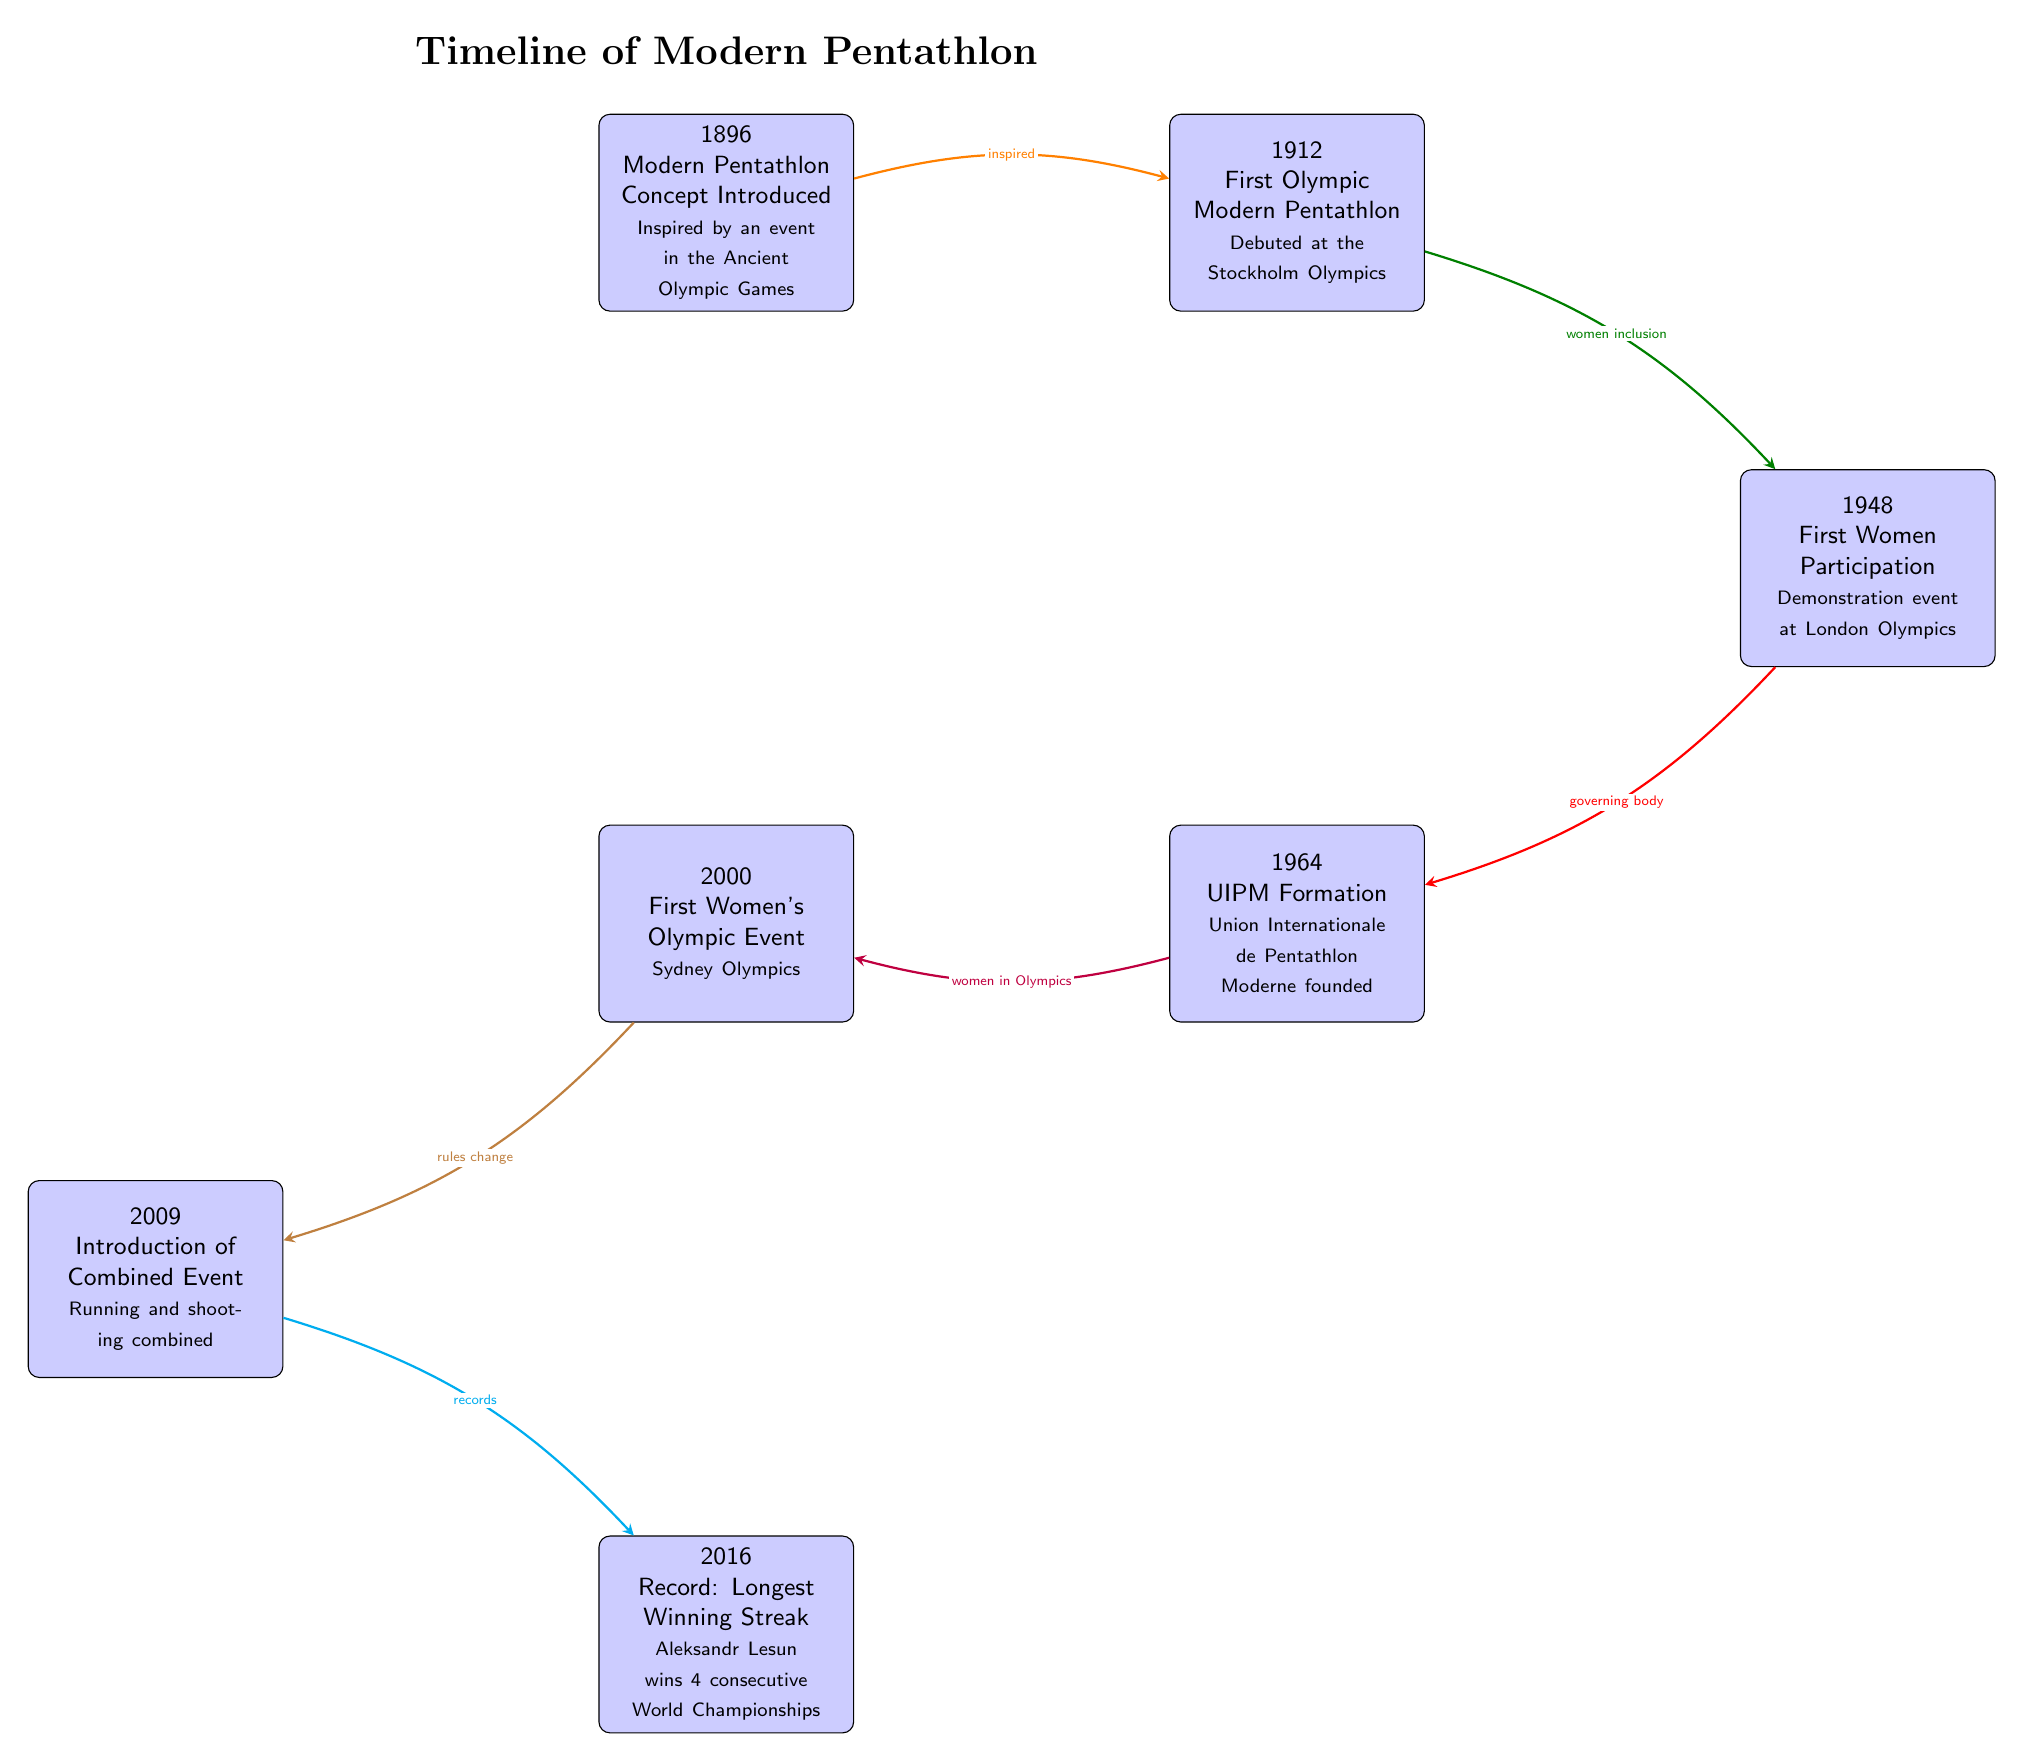What year was the Modern Pentathlon concept introduced? The diagram shows the node labeled "1896," which includes the text "Modern Pentathlon Concept Introduced." Therefore, the year mentioned is 1896.
Answer: 1896 What significant event related to women in modern pentathlon occurred in 1948? The node for the year "1948" specifies "First Women Participation," indicating that this was the significant event pertaining to women in modern pentathlon that year.
Answer: First Women Participation How many major events are listed in the timeline? By counting the event nodes in the diagram, we see there are 6: 1896, 1912, 1948, 1964, 2000, 2009, and 2016, resulting in a total of 6.
Answer: 6 What record was set in 2016? The node for the year "2016" notes "Record: Longest Winning Streak," which identifies the specific record that was achieved that year.
Answer: Longest Winning Streak What relationship does the arrow from 1896 to 1912 represent? The arrow from "1896" to "1912" is labeled "inspired," indicating that the introduction of modern pentathlon in 1896 inspired its first Olympic appearance in 1912.
Answer: inspired What key development occurred in 1964? The event in 1964 is labeled "UIPM Formation," which indicates that the Union Internationale de Pentathlon Moderne was founded at that time.
Answer: UIPM Formation What is the main connection between the years 2000 and 2009? The arrow from "2000" to "2009" is labeled "rules change," indicating that a significant change in the rules of the sport occurred between these two years.
Answer: rules change Who achieved a notable record in 2016? The event in 2016 refers to "Aleksandr Lesun wins 4 consecutive World Championships," specifying the individual responsible for the notable achievement.
Answer: Aleksandr Lesun What milestone did the year 2000 represent for women's participation? The node labeled "2000" states "First Women's Olympic Event," marking it as the first time women competed in the Olympic modern pentathlon.
Answer: First Women's Olympic Event 